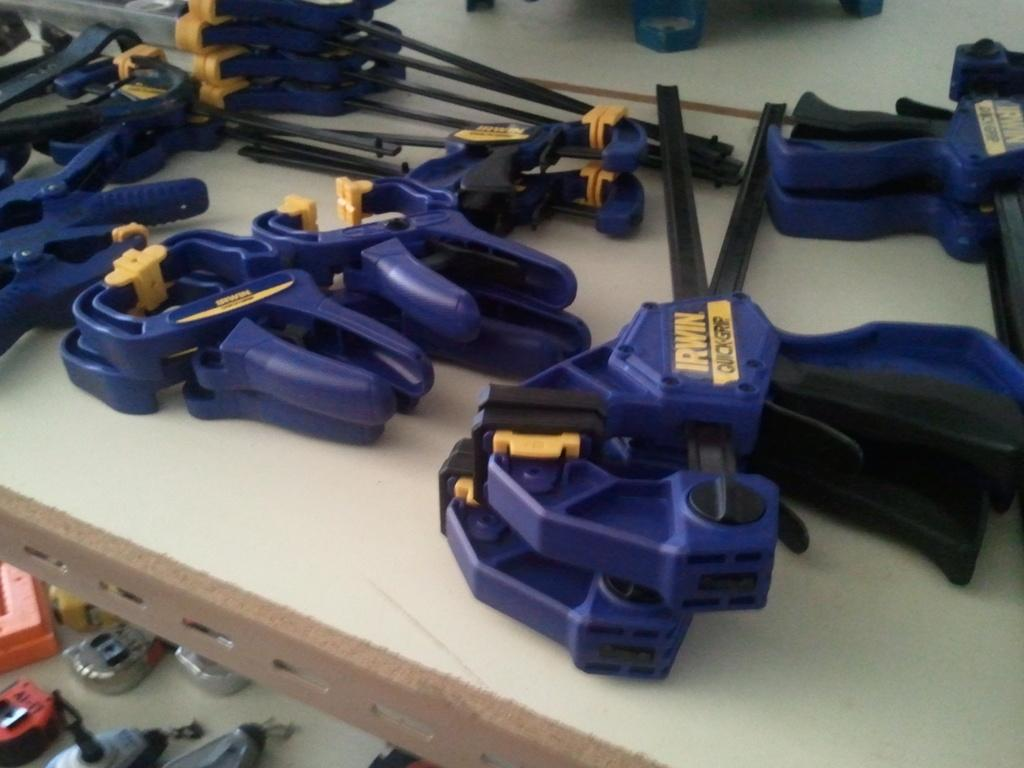What can be seen in the image? There are many tools in the image. Where are the tools placed? The tools are kept on a rack. What is visible at the bottom of the image? There are many things at the bottom of the image. What color are the tools? The tools are in blue color. How many hands are visible in the image? There are no hands visible in the image; it only shows tools on a rack. 